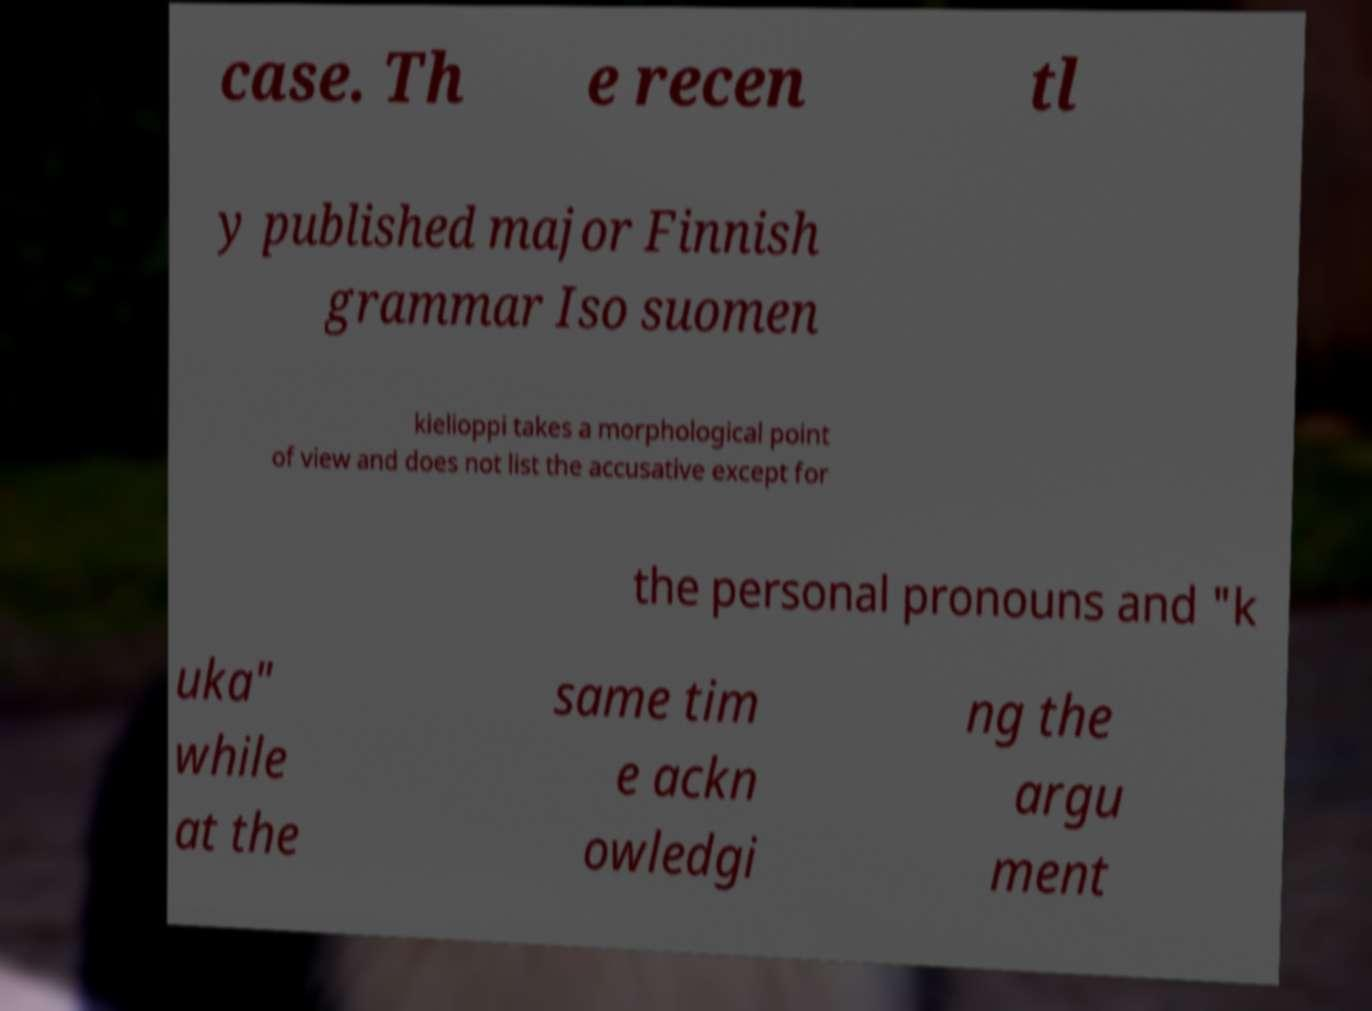I need the written content from this picture converted into text. Can you do that? case. Th e recen tl y published major Finnish grammar Iso suomen kielioppi takes a morphological point of view and does not list the accusative except for the personal pronouns and "k uka" while at the same tim e ackn owledgi ng the argu ment 